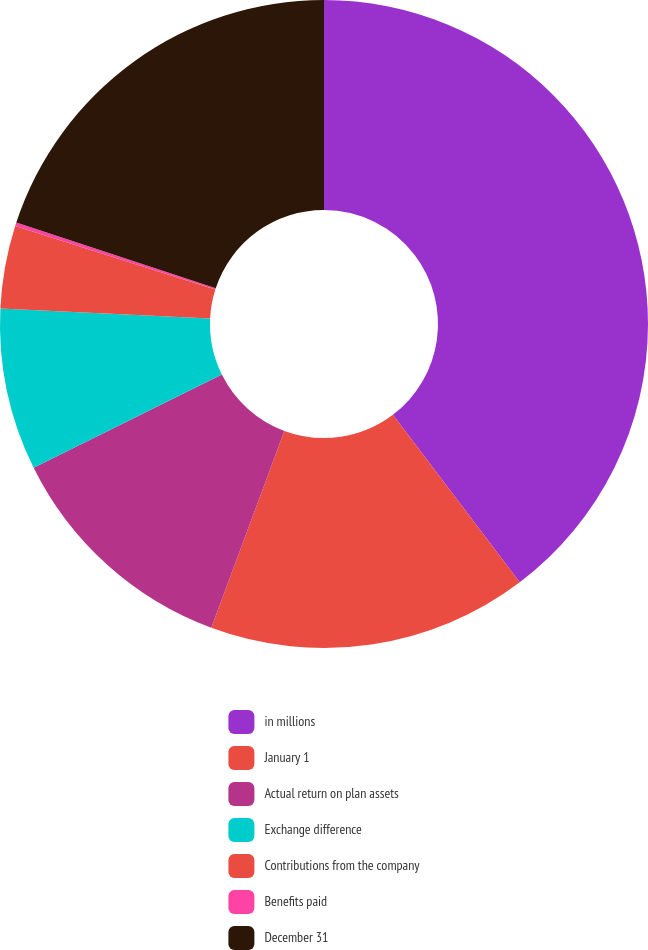Convert chart. <chart><loc_0><loc_0><loc_500><loc_500><pie_chart><fcel>in millions<fcel>January 1<fcel>Actual return on plan assets<fcel>Exchange difference<fcel>Contributions from the company<fcel>Benefits paid<fcel>December 31<nl><fcel>39.68%<fcel>15.98%<fcel>12.03%<fcel>8.08%<fcel>4.13%<fcel>0.18%<fcel>19.93%<nl></chart> 